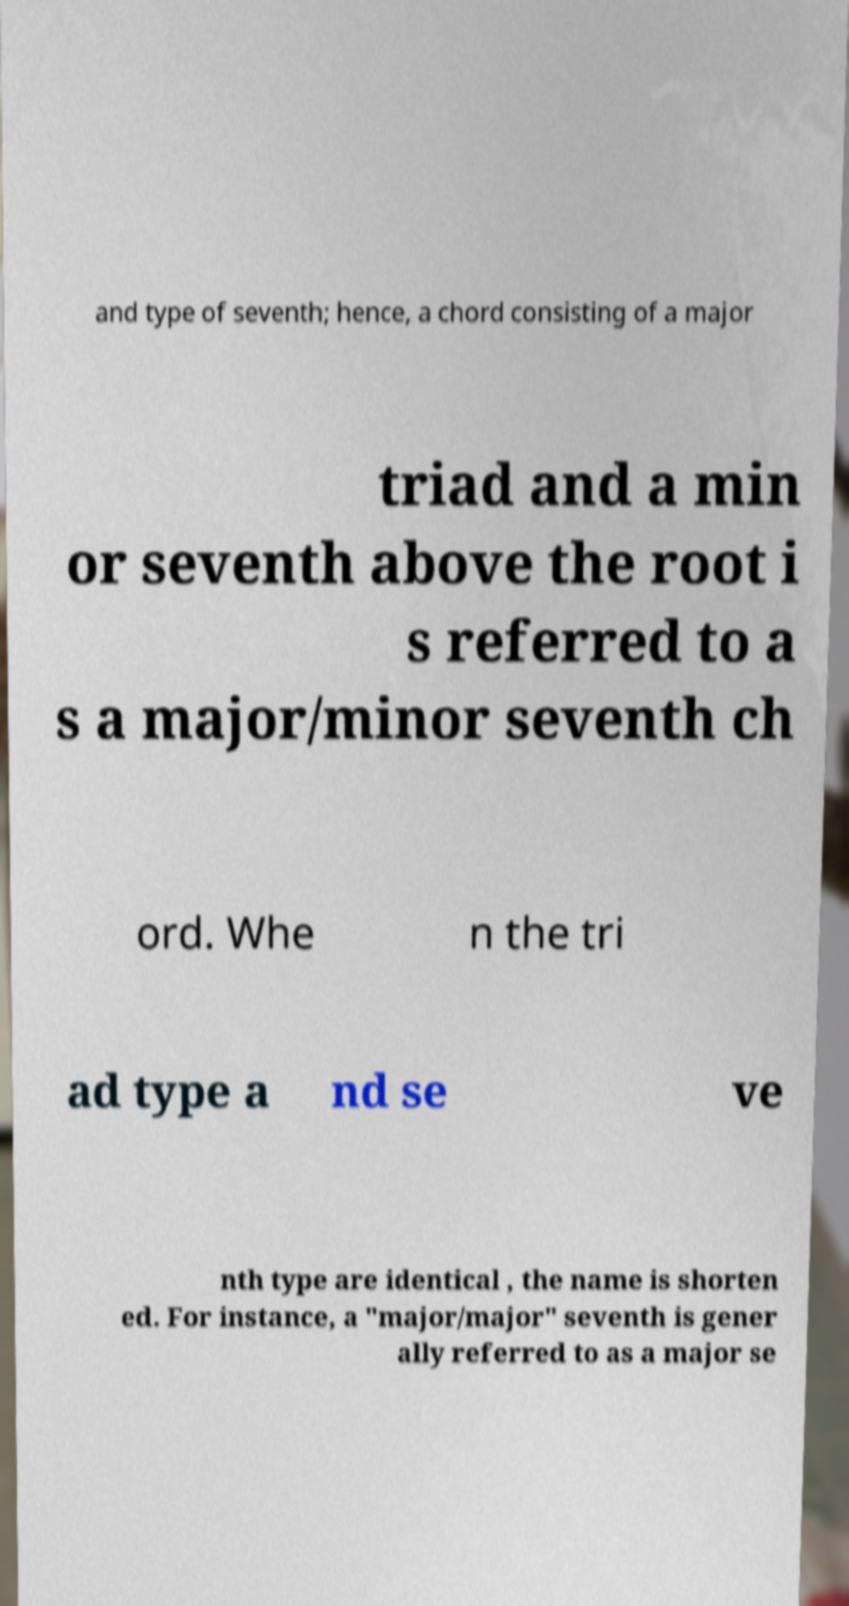Can you read and provide the text displayed in the image?This photo seems to have some interesting text. Can you extract and type it out for me? and type of seventh; hence, a chord consisting of a major triad and a min or seventh above the root i s referred to a s a major/minor seventh ch ord. Whe n the tri ad type a nd se ve nth type are identical , the name is shorten ed. For instance, a "major/major" seventh is gener ally referred to as a major se 